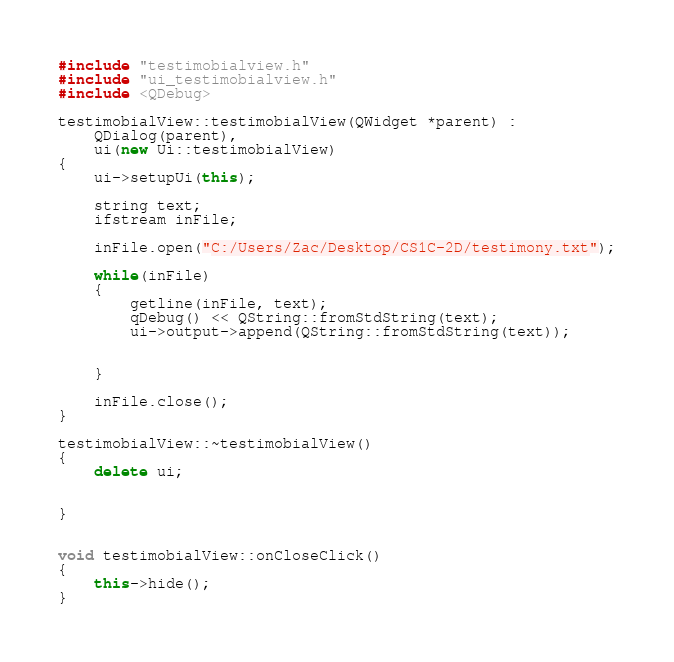Convert code to text. <code><loc_0><loc_0><loc_500><loc_500><_C++_>#include "testimobialview.h"
#include "ui_testimobialview.h"
#include <QDebug>

testimobialView::testimobialView(QWidget *parent) :
    QDialog(parent),
    ui(new Ui::testimobialView)
{
    ui->setupUi(this);

    string text;
    ifstream inFile;

    inFile.open("C:/Users/Zac/Desktop/CS1C-2D/testimony.txt");

    while(inFile)
    {
        getline(inFile, text);
        qDebug() << QString::fromStdString(text);
        ui->output->append(QString::fromStdString(text));


    }

    inFile.close();
}

testimobialView::~testimobialView()
{
    delete ui;


}


void testimobialView::onCloseClick()
{
    this->hide();
}
</code> 